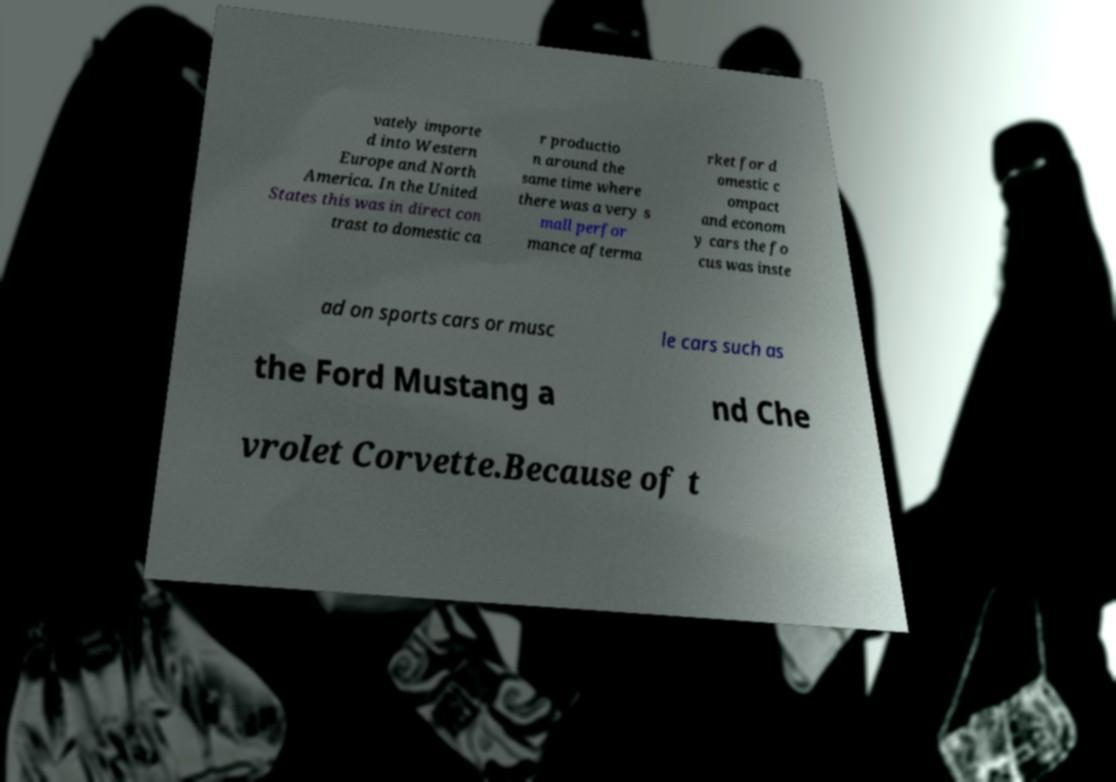What messages or text are displayed in this image? I need them in a readable, typed format. vately importe d into Western Europe and North America. In the United States this was in direct con trast to domestic ca r productio n around the same time where there was a very s mall perfor mance afterma rket for d omestic c ompact and econom y cars the fo cus was inste ad on sports cars or musc le cars such as the Ford Mustang a nd Che vrolet Corvette.Because of t 